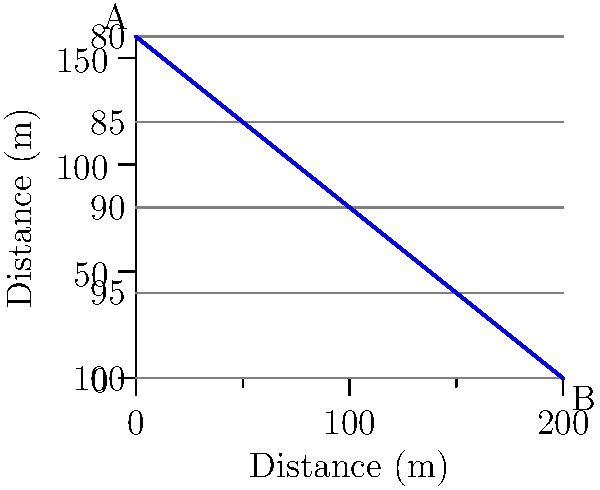As a neighbor with experience in landscaping, you're asked to help determine the optimal slope for proper drainage in a new residential area. Given the topographical map above, what is the average slope between points A and B, and is it suitable for residential drainage? To determine the average slope between points A and B, we need to follow these steps:

1. Calculate the change in elevation (rise):
   Elevation at A = 100 m
   Elevation at B = 80 m
   Rise = 100 m - 80 m = 20 m

2. Calculate the horizontal distance (run):
   The map shows a total horizontal distance of 200 m

3. Calculate the slope using the formula:
   Slope = Rise / Run
   Slope = 20 m / 200 m = 0.1 or 10%

4. Evaluate the suitability for residential drainage:
   For residential areas, a slope between 1% and 5% is generally considered optimal for proper drainage without causing erosion or water accumulation. 

   The calculated slope of 10% is steeper than the recommended range. While it will provide good drainage, it may be too steep for comfortable use in a residential setting and could potentially cause erosion issues.

5. Recommendation:
   To achieve an optimal slope, consider terracing the land or implementing a more gradual drainage path that follows the contour lines more closely. This would reduce the overall slope while still maintaining effective drainage.
Answer: The average slope is 10%, which is steeper than the optimal 1-5% range for residential drainage. 